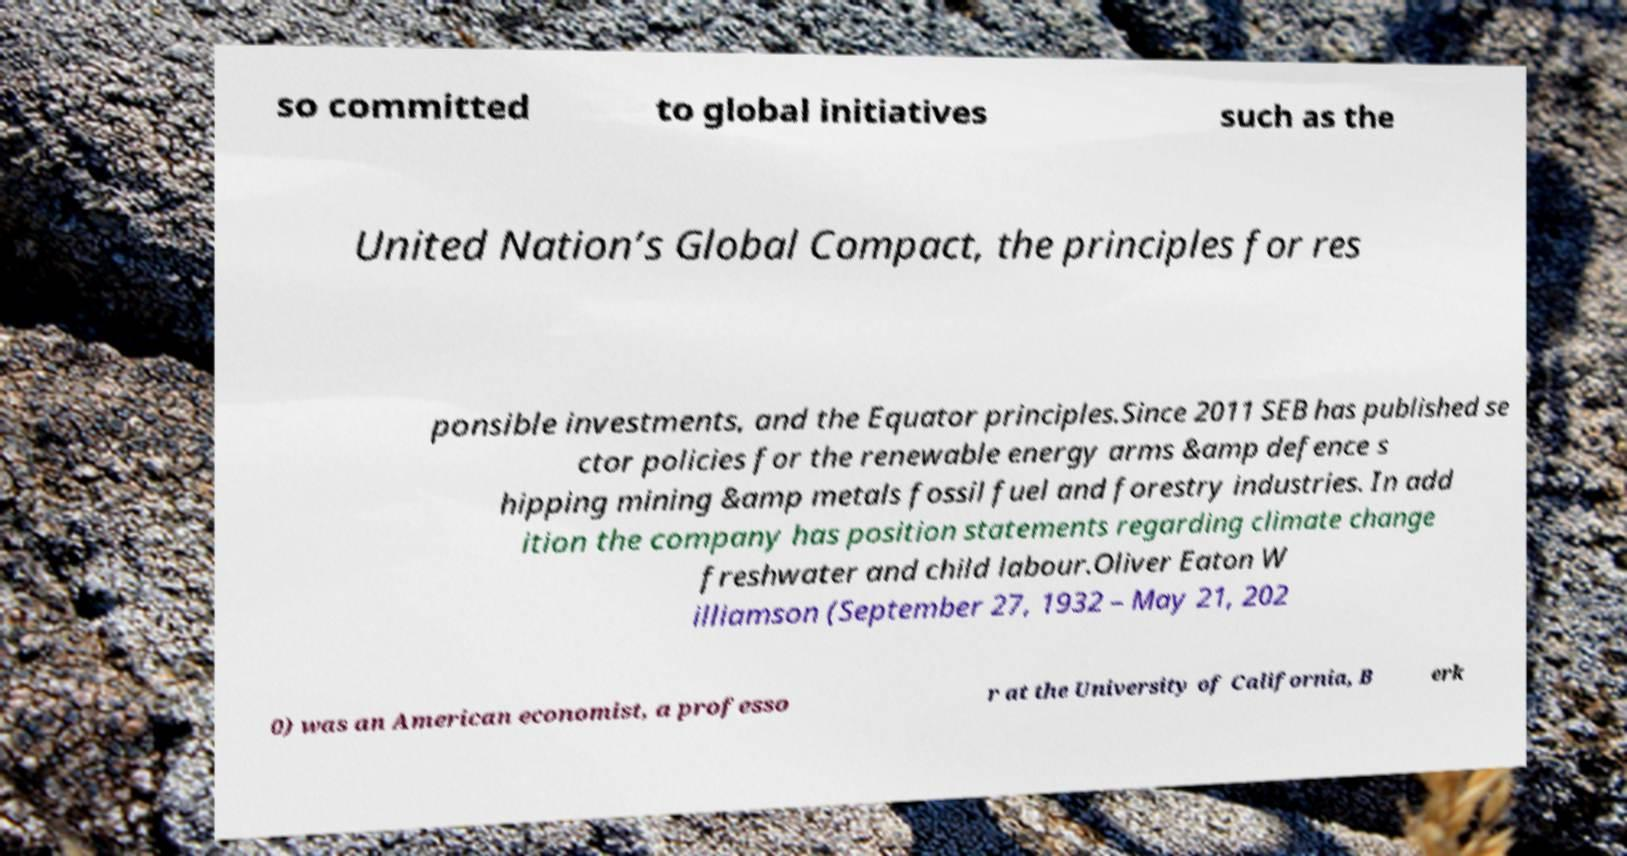Can you accurately transcribe the text from the provided image for me? so committed to global initiatives such as the United Nation’s Global Compact, the principles for res ponsible investments, and the Equator principles.Since 2011 SEB has published se ctor policies for the renewable energy arms &amp defence s hipping mining &amp metals fossil fuel and forestry industries. In add ition the company has position statements regarding climate change freshwater and child labour.Oliver Eaton W illiamson (September 27, 1932 – May 21, 202 0) was an American economist, a professo r at the University of California, B erk 